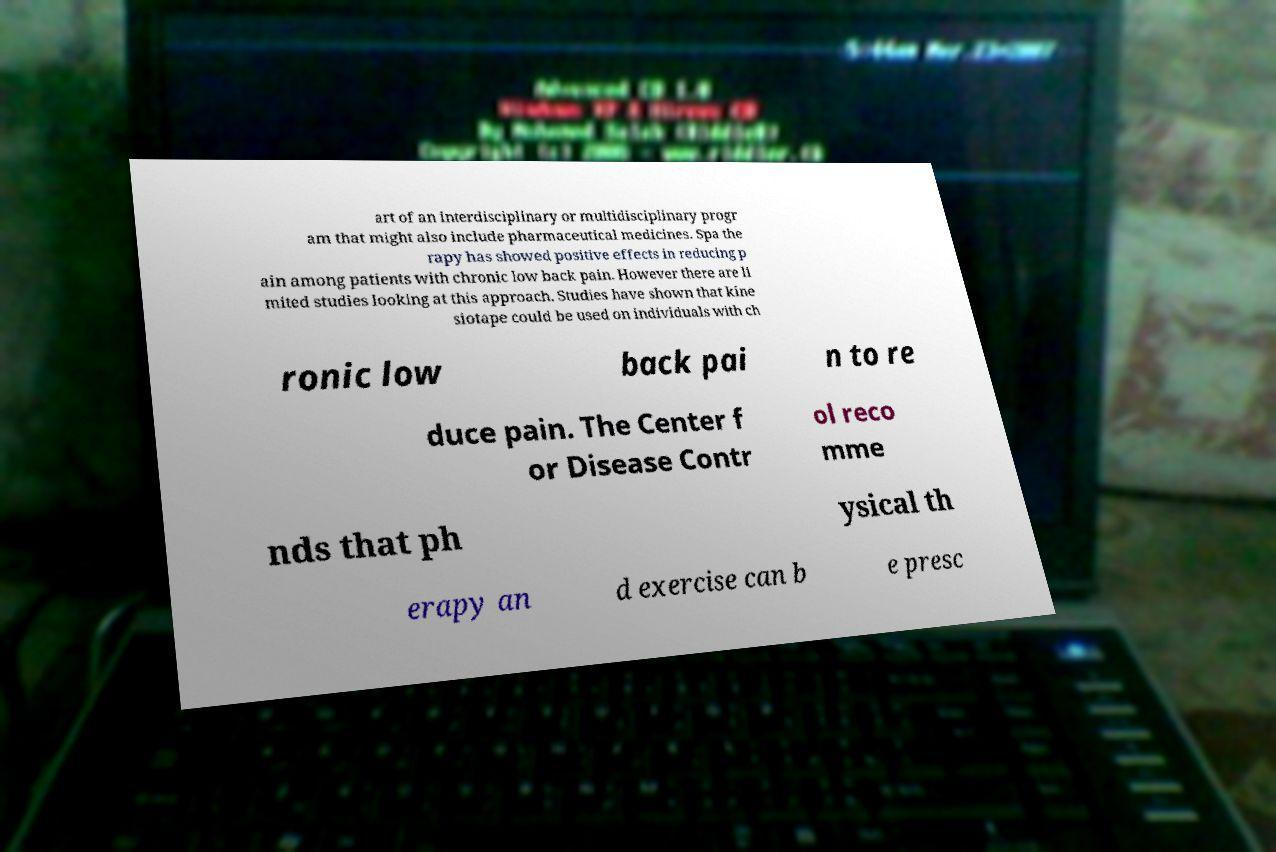Can you read and provide the text displayed in the image?This photo seems to have some interesting text. Can you extract and type it out for me? art of an interdisciplinary or multidisciplinary progr am that might also include pharmaceutical medicines. Spa the rapy has showed positive effects in reducing p ain among patients with chronic low back pain. However there are li mited studies looking at this approach. Studies have shown that kine siotape could be used on individuals with ch ronic low back pai n to re duce pain. The Center f or Disease Contr ol reco mme nds that ph ysical th erapy an d exercise can b e presc 